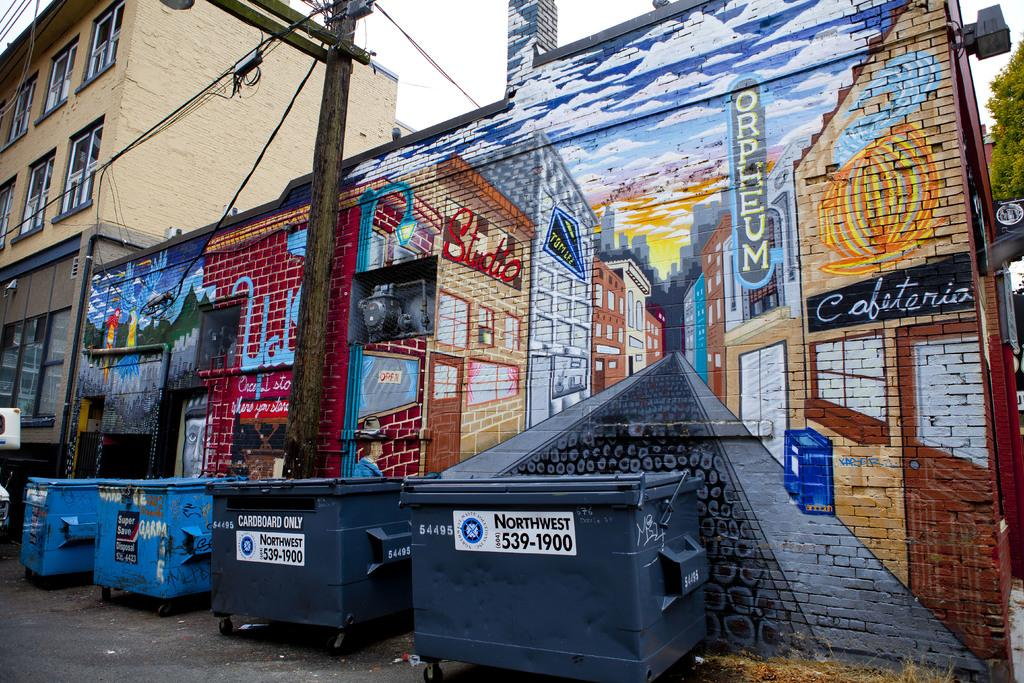<image>
Render a clear and concise summary of the photo. Garbage can in an alley that has the sticker "Northwest" on it. 